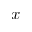<formula> <loc_0><loc_0><loc_500><loc_500>x</formula> 